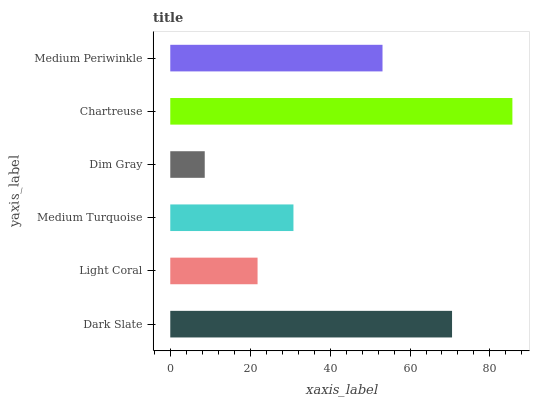Is Dim Gray the minimum?
Answer yes or no. Yes. Is Chartreuse the maximum?
Answer yes or no. Yes. Is Light Coral the minimum?
Answer yes or no. No. Is Light Coral the maximum?
Answer yes or no. No. Is Dark Slate greater than Light Coral?
Answer yes or no. Yes. Is Light Coral less than Dark Slate?
Answer yes or no. Yes. Is Light Coral greater than Dark Slate?
Answer yes or no. No. Is Dark Slate less than Light Coral?
Answer yes or no. No. Is Medium Periwinkle the high median?
Answer yes or no. Yes. Is Medium Turquoise the low median?
Answer yes or no. Yes. Is Chartreuse the high median?
Answer yes or no. No. Is Chartreuse the low median?
Answer yes or no. No. 